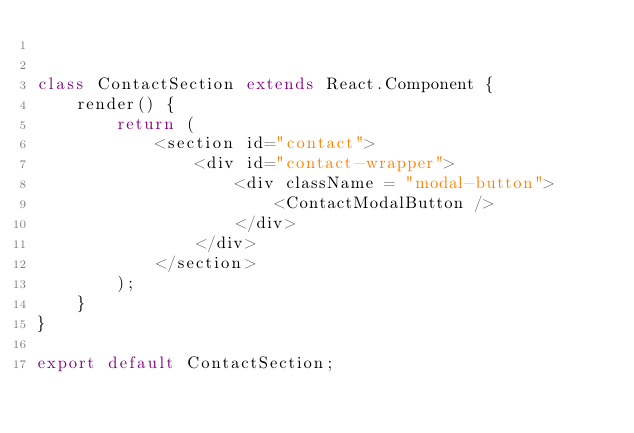Convert code to text. <code><loc_0><loc_0><loc_500><loc_500><_JavaScript_>

class ContactSection extends React.Component {
    render() {
        return (
            <section id="contact">
                <div id="contact-wrapper">
                    <div className = "modal-button">
                        <ContactModalButton />
                    </div>
                </div>
            </section>
        );
    }
}

export default ContactSection;</code> 